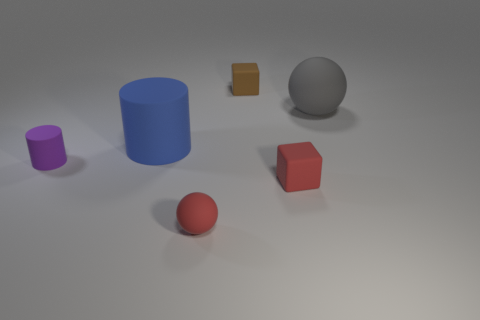What is the size of the rubber thing that is the same color as the small sphere?
Your answer should be very brief. Small. The other matte object that is the same shape as the gray object is what size?
Your answer should be very brief. Small. Is there anything else that has the same material as the brown block?
Your answer should be very brief. Yes. Are there any gray cylinders?
Offer a very short reply. No. Does the tiny sphere have the same color as the small cube right of the small brown thing?
Your answer should be compact. Yes. What is the size of the ball that is behind the small red thing in front of the tiny red rubber thing to the right of the red ball?
Your answer should be compact. Large. What number of tiny matte balls have the same color as the small cylinder?
Make the answer very short. 0. What number of objects are tiny purple matte cylinders or objects that are in front of the tiny cylinder?
Your answer should be compact. 3. The large cylinder has what color?
Your answer should be compact. Blue. The rubber cube that is on the right side of the small brown thing is what color?
Make the answer very short. Red. 